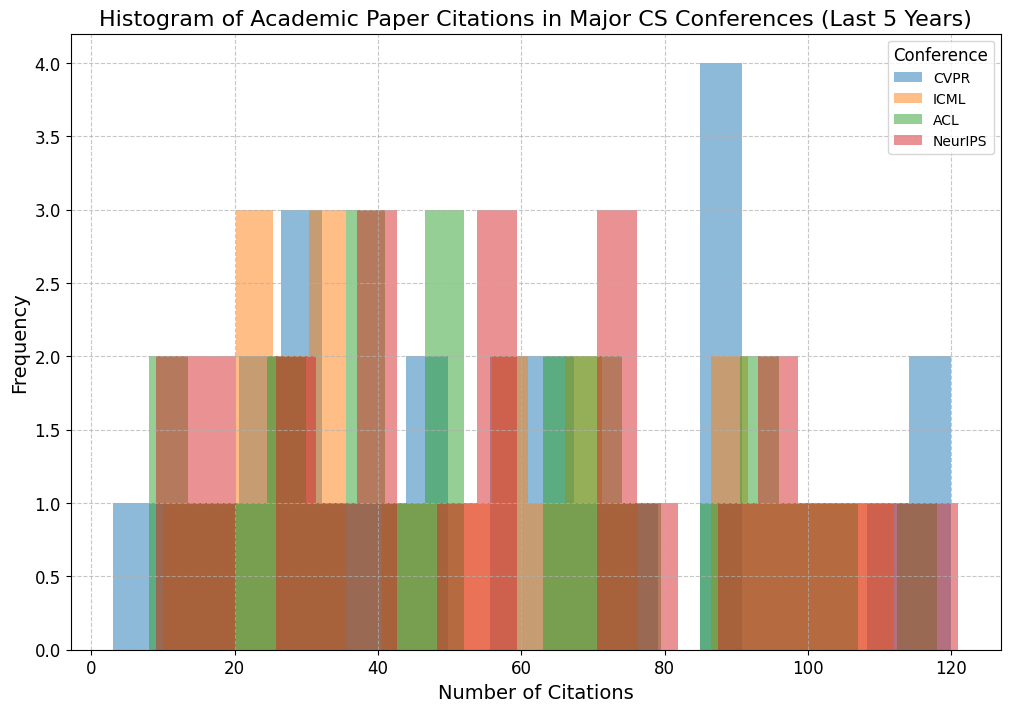what is the conference with the highest peak in citation frequency? To identify the conference with the highest peak in citation frequency, we look at the tallest bar in the histogram. The tallest bar indicates the highest frequency of citations for a particular conference. By observing the different colors and bar heights, NeurIPS appears to have the highest peak.
Answer: NeurIPS which conference shows the lowest frequency of citations in the 0-20 citations range? To determine which conference has the least frequency in the 0-20 citations range, we observe the bars within this range for each color representing conferences. ACL, represented by green bars, appears to have fewer bars in this range compared to other conferences.
Answer: ACL compare the citation frequencies for CVPR and ICML in the range 60-80 citations By examining the bars between 60 and 80 citations for both CVPR (blue) and ICML (orange), we see CVPR has more bars and thus a higher frequency. Therefore, CVPR has more citations in this range compared to ICML.
Answer: CVPR which conference appears to have citations more evenly distributed across different ranges? By analyzing the histogram, we note that ICML (orange bars) appears to have a more even spread of citations across different ranges, with relatively balanced frequencies in both lower and higher citation ranges.
Answer: ICML what can be inferred about the 100+ citations range among all conferences? When we observe the bars beyond the 100 citations mark, it is evident that all conferences have a few papers with citations above 100, but NeurIPS and CVPR have more noticeable peaks compared to ICML and ACL. In particular, NeurIPS has relatively higher frequencies in this range.
Answer: NeurIPS and CVPR which year might have contributed the most to the high citation count in NeurIPS? To identify the year contributing most to the high citation count in NeurIPS, note the inclusion of several high citation counts in the data for 2021 and 2022. Confirmed by the taller red bars, these years have significantly high citation papers.
Answer: 2021 and 2022 